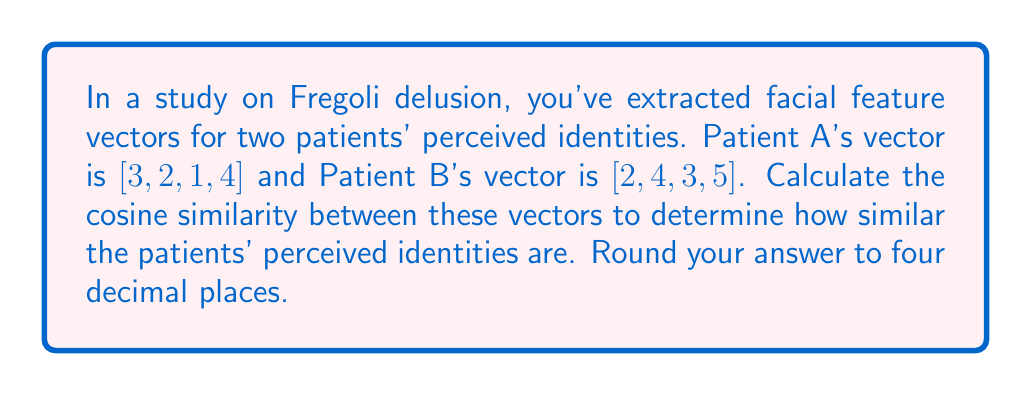Teach me how to tackle this problem. To compute the cosine similarity between two vectors, we use the formula:

$$\text{cosine similarity} = \frac{\mathbf{A} \cdot \mathbf{B}}{\|\mathbf{A}\| \|\mathbf{B}\|}$$

Where $\mathbf{A} \cdot \mathbf{B}$ is the dot product of the vectors, and $\|\mathbf{A}\|$ and $\|\mathbf{B}\|$ are the magnitudes (Euclidean norms) of vectors $\mathbf{A}$ and $\mathbf{B}$ respectively.

1. Calculate the dot product $\mathbf{A} \cdot \mathbf{B}$:
   $$(3 \times 2) + (2 \times 4) + (1 \times 3) + (4 \times 5) = 6 + 8 + 3 + 20 = 37$$

2. Calculate $\|\mathbf{A}\|$:
   $$\|\mathbf{A}\| = \sqrt{3^2 + 2^2 + 1^2 + 4^2} = \sqrt{9 + 4 + 1 + 16} = \sqrt{30} \approx 5.4772$$

3. Calculate $\|\mathbf{B}\|$:
   $$\|\mathbf{B}\| = \sqrt{2^2 + 4^2 + 3^2 + 5^2} = \sqrt{4 + 16 + 9 + 25} = \sqrt{54} \approx 7.3485$$

4. Apply the cosine similarity formula:
   $$\text{cosine similarity} = \frac{37}{5.4772 \times 7.3485} \approx 0.9186$$

5. Round to four decimal places: 0.9186
Answer: 0.9186 